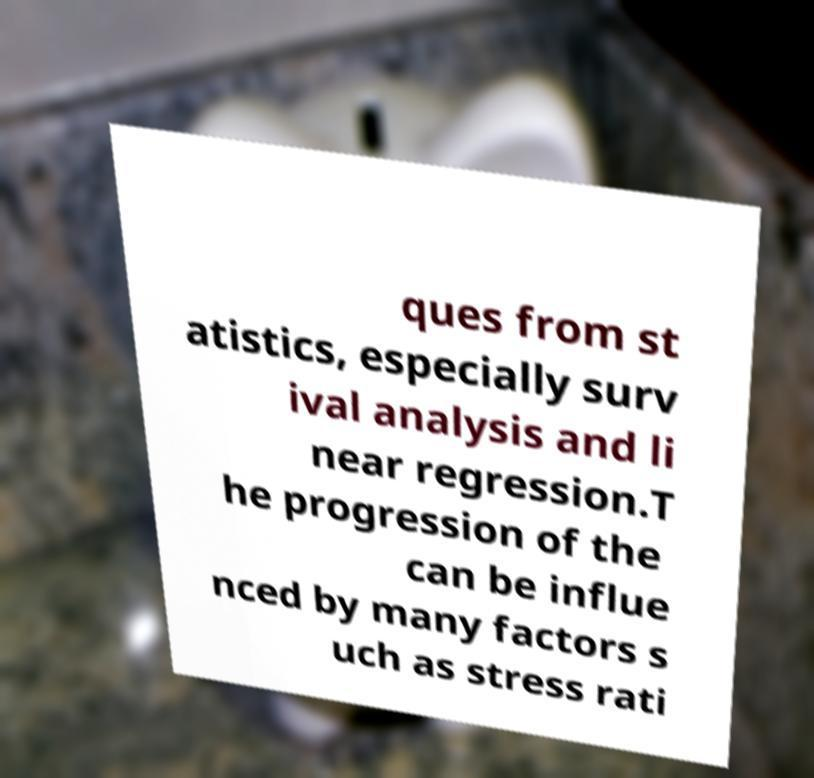Can you read and provide the text displayed in the image?This photo seems to have some interesting text. Can you extract and type it out for me? ques from st atistics, especially surv ival analysis and li near regression.T he progression of the can be influe nced by many factors s uch as stress rati 